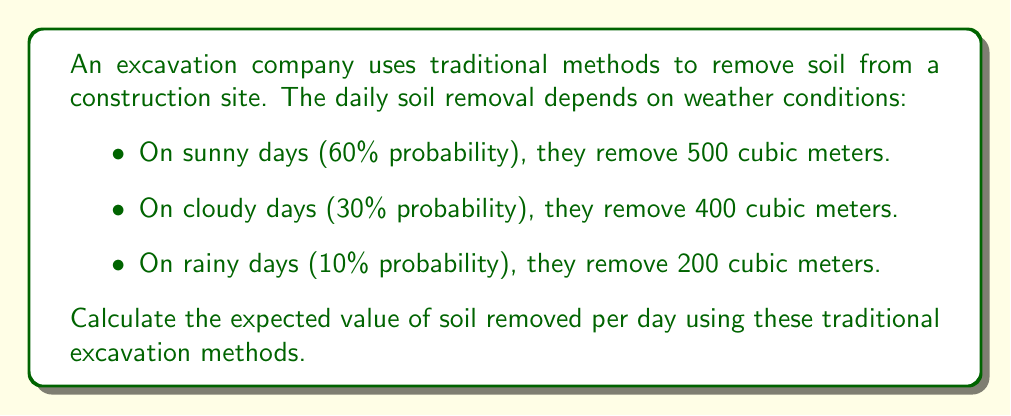What is the answer to this math problem? To calculate the expected value, we need to:
1. Multiply each possible outcome by its probability
2. Sum all these products

Let's break it down step-by-step:

1. Sunny days:
   Probability = 0.60
   Soil removed = 500 cubic meters
   $$ 0.60 \times 500 = 300 $$

2. Cloudy days:
   Probability = 0.30
   Soil removed = 400 cubic meters
   $$ 0.30 \times 400 = 120 $$

3. Rainy days:
   Probability = 0.10
   Soil removed = 200 cubic meters
   $$ 0.10 \times 200 = 20 $$

4. Sum all products:
   $$ E(\text{soil removed}) = 300 + 120 + 20 = 440 $$

Therefore, the expected value of soil removed per day is 440 cubic meters.
Answer: 440 cubic meters 